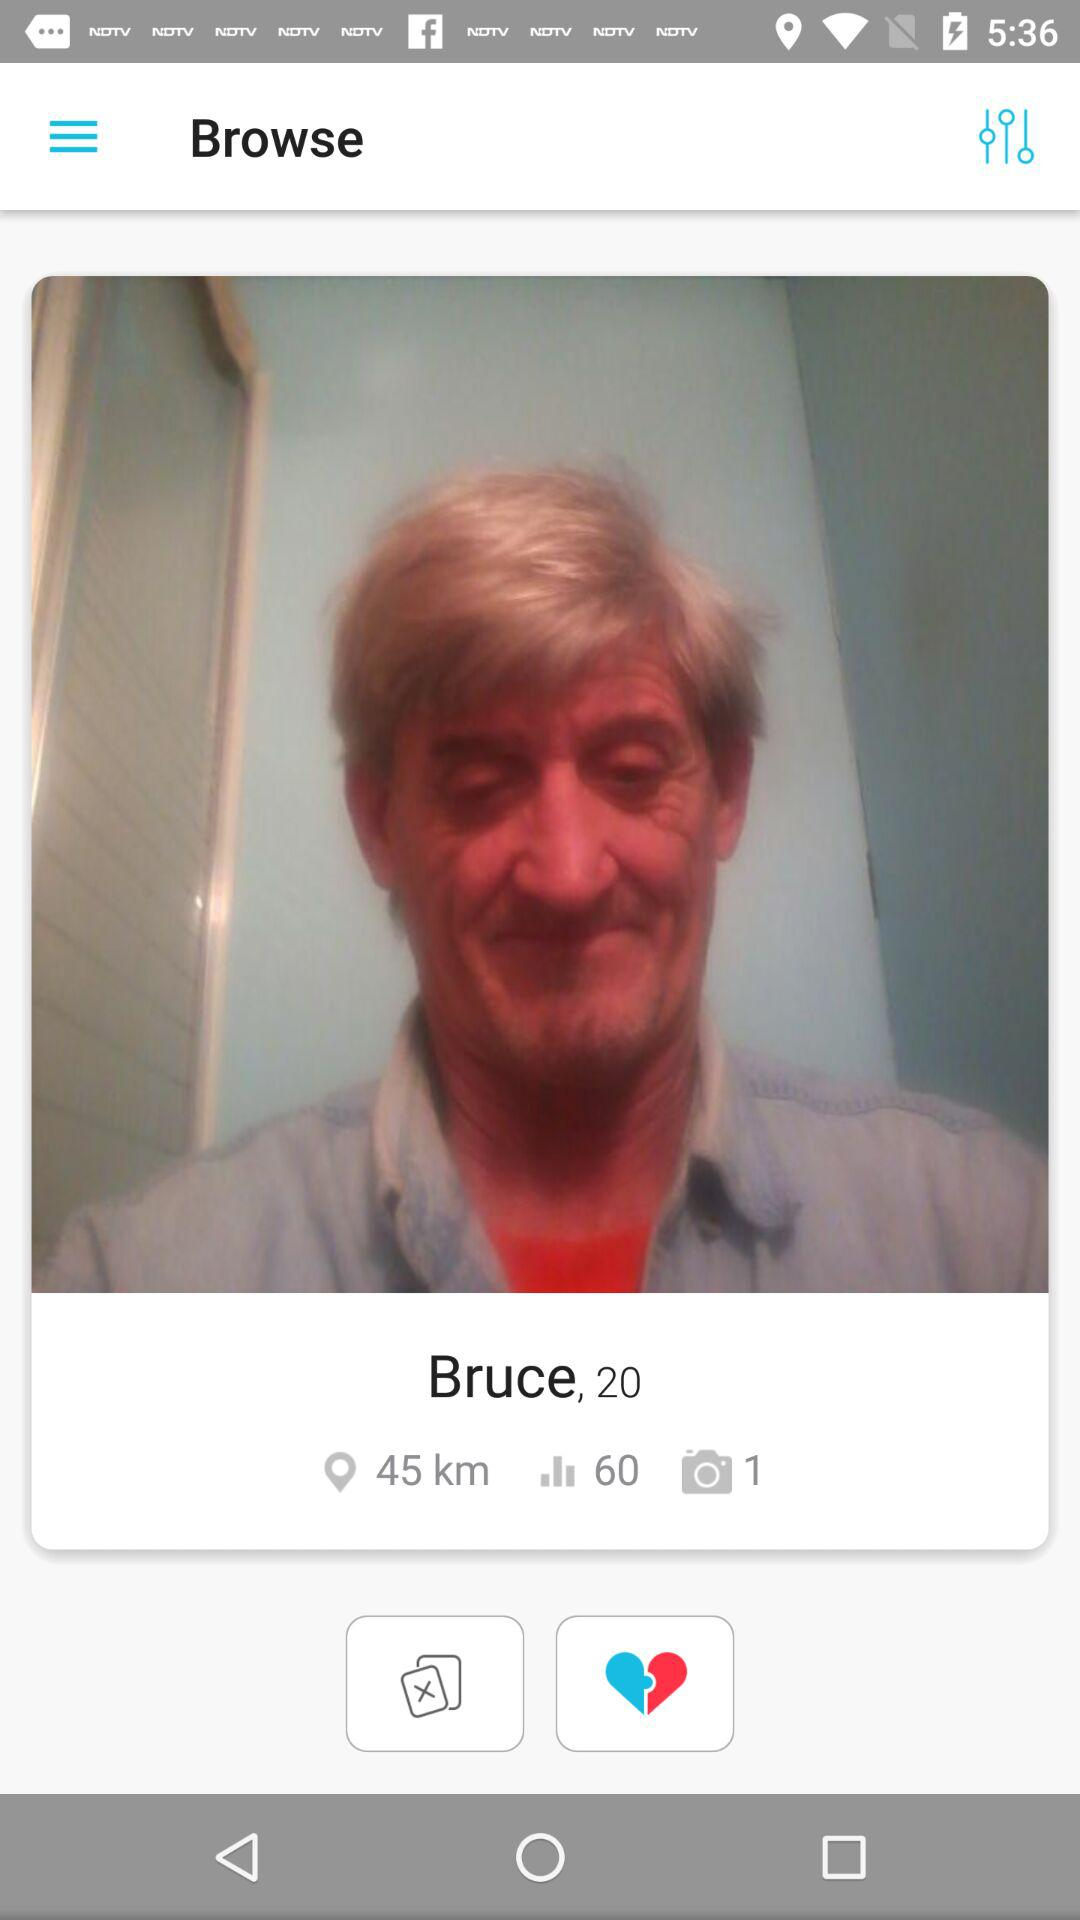What is the age of Bruce? Bruce is 20 years old. 